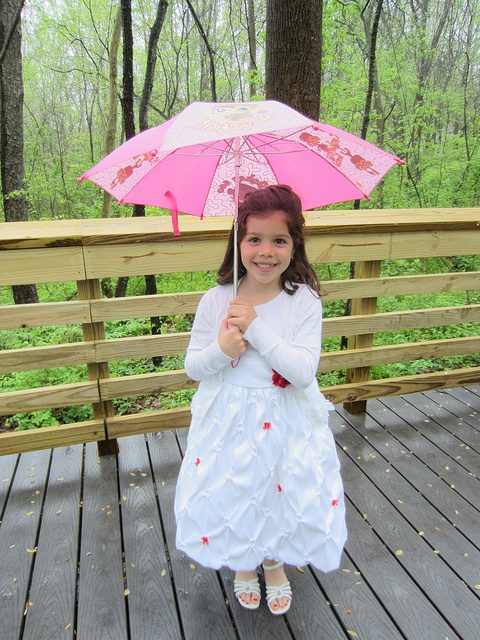Describe the objects in this image and their specific colors. I can see people in black, lavender, lightgray, darkgray, and tan tones and umbrella in black, violet, lavender, and lightpink tones in this image. 